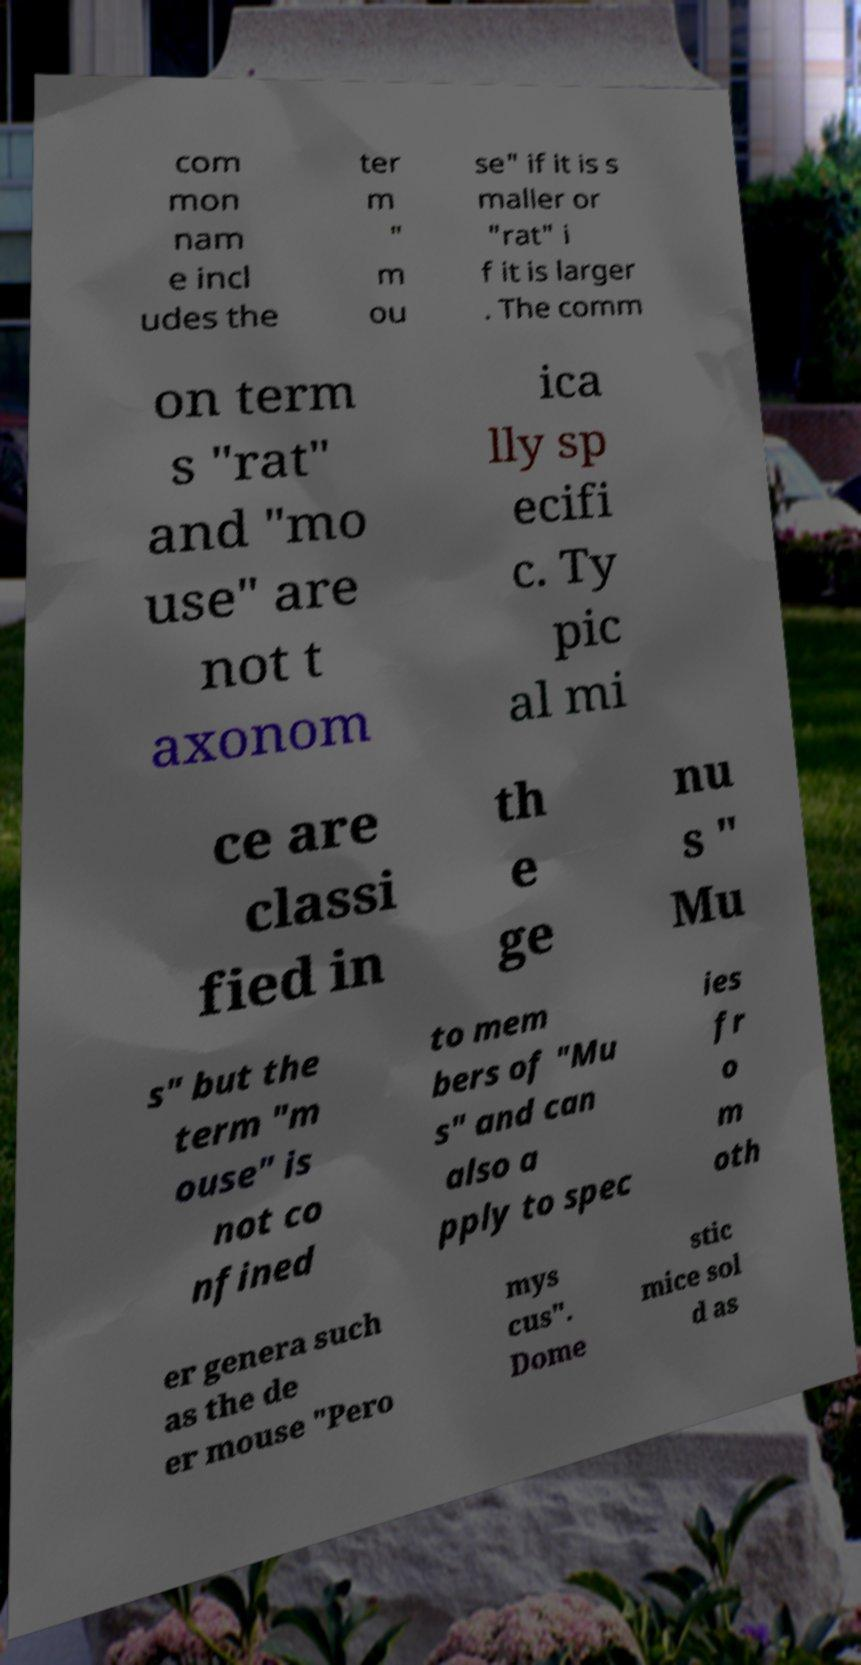Please read and relay the text visible in this image. What does it say? com mon nam e incl udes the ter m " m ou se" if it is s maller or "rat" i f it is larger . The comm on term s "rat" and "mo use" are not t axonom ica lly sp ecifi c. Ty pic al mi ce are classi fied in th e ge nu s " Mu s" but the term "m ouse" is not co nfined to mem bers of "Mu s" and can also a pply to spec ies fr o m oth er genera such as the de er mouse "Pero mys cus". Dome stic mice sol d as 